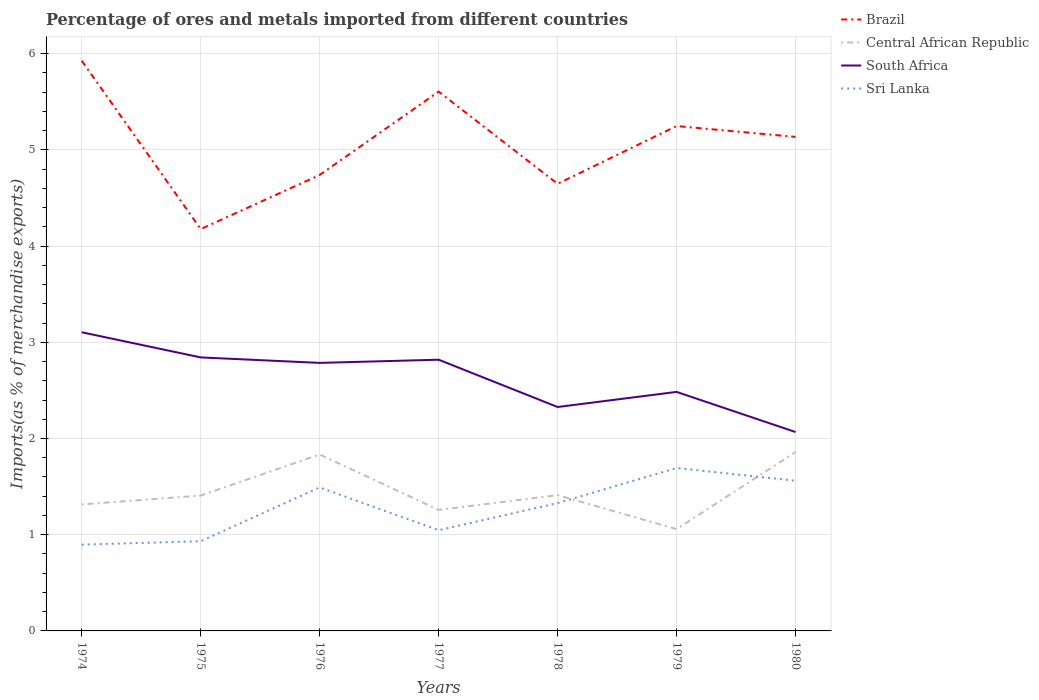How many different coloured lines are there?
Your response must be concise. 4. Is the number of lines equal to the number of legend labels?
Your answer should be very brief. Yes. Across all years, what is the maximum percentage of imports to different countries in Brazil?
Provide a short and direct response. 4.18. In which year was the percentage of imports to different countries in South Africa maximum?
Make the answer very short. 1980. What is the total percentage of imports to different countries in Sri Lanka in the graph?
Make the answer very short. 0.13. What is the difference between the highest and the second highest percentage of imports to different countries in Sri Lanka?
Your answer should be very brief. 0.8. What is the difference between the highest and the lowest percentage of imports to different countries in Brazil?
Keep it short and to the point. 4. How many lines are there?
Provide a short and direct response. 4. What is the difference between two consecutive major ticks on the Y-axis?
Offer a terse response. 1. Where does the legend appear in the graph?
Provide a succinct answer. Top right. How are the legend labels stacked?
Ensure brevity in your answer.  Vertical. What is the title of the graph?
Provide a succinct answer. Percentage of ores and metals imported from different countries. Does "Bahamas" appear as one of the legend labels in the graph?
Your answer should be very brief. No. What is the label or title of the X-axis?
Ensure brevity in your answer.  Years. What is the label or title of the Y-axis?
Provide a succinct answer. Imports(as % of merchandise exports). What is the Imports(as % of merchandise exports) in Brazil in 1974?
Offer a terse response. 5.93. What is the Imports(as % of merchandise exports) in Central African Republic in 1974?
Offer a terse response. 1.31. What is the Imports(as % of merchandise exports) in South Africa in 1974?
Provide a succinct answer. 3.1. What is the Imports(as % of merchandise exports) in Sri Lanka in 1974?
Provide a short and direct response. 0.9. What is the Imports(as % of merchandise exports) in Brazil in 1975?
Your answer should be very brief. 4.18. What is the Imports(as % of merchandise exports) of Central African Republic in 1975?
Offer a terse response. 1.41. What is the Imports(as % of merchandise exports) of South Africa in 1975?
Your answer should be compact. 2.84. What is the Imports(as % of merchandise exports) of Sri Lanka in 1975?
Your answer should be very brief. 0.93. What is the Imports(as % of merchandise exports) of Brazil in 1976?
Your answer should be compact. 4.74. What is the Imports(as % of merchandise exports) in Central African Republic in 1976?
Provide a succinct answer. 1.83. What is the Imports(as % of merchandise exports) in South Africa in 1976?
Your answer should be compact. 2.79. What is the Imports(as % of merchandise exports) of Sri Lanka in 1976?
Your answer should be compact. 1.49. What is the Imports(as % of merchandise exports) in Brazil in 1977?
Provide a succinct answer. 5.61. What is the Imports(as % of merchandise exports) of Central African Republic in 1977?
Offer a very short reply. 1.26. What is the Imports(as % of merchandise exports) in South Africa in 1977?
Provide a short and direct response. 2.82. What is the Imports(as % of merchandise exports) of Sri Lanka in 1977?
Your response must be concise. 1.05. What is the Imports(as % of merchandise exports) in Brazil in 1978?
Your response must be concise. 4.65. What is the Imports(as % of merchandise exports) of Central African Republic in 1978?
Your answer should be very brief. 1.41. What is the Imports(as % of merchandise exports) in South Africa in 1978?
Offer a terse response. 2.33. What is the Imports(as % of merchandise exports) of Sri Lanka in 1978?
Keep it short and to the point. 1.33. What is the Imports(as % of merchandise exports) in Brazil in 1979?
Offer a terse response. 5.25. What is the Imports(as % of merchandise exports) of Central African Republic in 1979?
Give a very brief answer. 1.06. What is the Imports(as % of merchandise exports) of South Africa in 1979?
Offer a terse response. 2.48. What is the Imports(as % of merchandise exports) in Sri Lanka in 1979?
Make the answer very short. 1.69. What is the Imports(as % of merchandise exports) in Brazil in 1980?
Your answer should be very brief. 5.14. What is the Imports(as % of merchandise exports) in Central African Republic in 1980?
Your answer should be compact. 1.86. What is the Imports(as % of merchandise exports) in South Africa in 1980?
Make the answer very short. 2.07. What is the Imports(as % of merchandise exports) of Sri Lanka in 1980?
Your answer should be very brief. 1.56. Across all years, what is the maximum Imports(as % of merchandise exports) in Brazil?
Your answer should be compact. 5.93. Across all years, what is the maximum Imports(as % of merchandise exports) in Central African Republic?
Give a very brief answer. 1.86. Across all years, what is the maximum Imports(as % of merchandise exports) in South Africa?
Provide a short and direct response. 3.1. Across all years, what is the maximum Imports(as % of merchandise exports) in Sri Lanka?
Offer a terse response. 1.69. Across all years, what is the minimum Imports(as % of merchandise exports) in Brazil?
Your response must be concise. 4.18. Across all years, what is the minimum Imports(as % of merchandise exports) in Central African Republic?
Keep it short and to the point. 1.06. Across all years, what is the minimum Imports(as % of merchandise exports) in South Africa?
Offer a very short reply. 2.07. Across all years, what is the minimum Imports(as % of merchandise exports) of Sri Lanka?
Provide a succinct answer. 0.9. What is the total Imports(as % of merchandise exports) in Brazil in the graph?
Provide a short and direct response. 35.48. What is the total Imports(as % of merchandise exports) of Central African Republic in the graph?
Make the answer very short. 10.14. What is the total Imports(as % of merchandise exports) in South Africa in the graph?
Give a very brief answer. 18.43. What is the total Imports(as % of merchandise exports) in Sri Lanka in the graph?
Ensure brevity in your answer.  8.95. What is the difference between the Imports(as % of merchandise exports) of Brazil in 1974 and that in 1975?
Offer a very short reply. 1.75. What is the difference between the Imports(as % of merchandise exports) in Central African Republic in 1974 and that in 1975?
Offer a terse response. -0.09. What is the difference between the Imports(as % of merchandise exports) in South Africa in 1974 and that in 1975?
Give a very brief answer. 0.26. What is the difference between the Imports(as % of merchandise exports) of Sri Lanka in 1974 and that in 1975?
Your response must be concise. -0.04. What is the difference between the Imports(as % of merchandise exports) of Brazil in 1974 and that in 1976?
Your answer should be compact. 1.19. What is the difference between the Imports(as % of merchandise exports) in Central African Republic in 1974 and that in 1976?
Offer a terse response. -0.52. What is the difference between the Imports(as % of merchandise exports) in South Africa in 1974 and that in 1976?
Give a very brief answer. 0.32. What is the difference between the Imports(as % of merchandise exports) of Sri Lanka in 1974 and that in 1976?
Offer a very short reply. -0.59. What is the difference between the Imports(as % of merchandise exports) in Brazil in 1974 and that in 1977?
Provide a short and direct response. 0.32. What is the difference between the Imports(as % of merchandise exports) in Central African Republic in 1974 and that in 1977?
Provide a short and direct response. 0.06. What is the difference between the Imports(as % of merchandise exports) in South Africa in 1974 and that in 1977?
Provide a short and direct response. 0.29. What is the difference between the Imports(as % of merchandise exports) in Sri Lanka in 1974 and that in 1977?
Give a very brief answer. -0.15. What is the difference between the Imports(as % of merchandise exports) of Brazil in 1974 and that in 1978?
Ensure brevity in your answer.  1.28. What is the difference between the Imports(as % of merchandise exports) of Central African Republic in 1974 and that in 1978?
Provide a short and direct response. -0.1. What is the difference between the Imports(as % of merchandise exports) in South Africa in 1974 and that in 1978?
Your answer should be compact. 0.78. What is the difference between the Imports(as % of merchandise exports) in Sri Lanka in 1974 and that in 1978?
Your response must be concise. -0.43. What is the difference between the Imports(as % of merchandise exports) in Brazil in 1974 and that in 1979?
Keep it short and to the point. 0.68. What is the difference between the Imports(as % of merchandise exports) in Central African Republic in 1974 and that in 1979?
Make the answer very short. 0.26. What is the difference between the Imports(as % of merchandise exports) of South Africa in 1974 and that in 1979?
Your answer should be compact. 0.62. What is the difference between the Imports(as % of merchandise exports) of Sri Lanka in 1974 and that in 1979?
Offer a very short reply. -0.8. What is the difference between the Imports(as % of merchandise exports) of Brazil in 1974 and that in 1980?
Your answer should be very brief. 0.79. What is the difference between the Imports(as % of merchandise exports) in Central African Republic in 1974 and that in 1980?
Offer a very short reply. -0.54. What is the difference between the Imports(as % of merchandise exports) of South Africa in 1974 and that in 1980?
Provide a succinct answer. 1.04. What is the difference between the Imports(as % of merchandise exports) of Sri Lanka in 1974 and that in 1980?
Keep it short and to the point. -0.66. What is the difference between the Imports(as % of merchandise exports) of Brazil in 1975 and that in 1976?
Give a very brief answer. -0.56. What is the difference between the Imports(as % of merchandise exports) in Central African Republic in 1975 and that in 1976?
Provide a short and direct response. -0.43. What is the difference between the Imports(as % of merchandise exports) in South Africa in 1975 and that in 1976?
Keep it short and to the point. 0.06. What is the difference between the Imports(as % of merchandise exports) of Sri Lanka in 1975 and that in 1976?
Make the answer very short. -0.56. What is the difference between the Imports(as % of merchandise exports) of Brazil in 1975 and that in 1977?
Offer a terse response. -1.43. What is the difference between the Imports(as % of merchandise exports) in Central African Republic in 1975 and that in 1977?
Your answer should be very brief. 0.15. What is the difference between the Imports(as % of merchandise exports) of South Africa in 1975 and that in 1977?
Your response must be concise. 0.02. What is the difference between the Imports(as % of merchandise exports) in Sri Lanka in 1975 and that in 1977?
Provide a succinct answer. -0.11. What is the difference between the Imports(as % of merchandise exports) in Brazil in 1975 and that in 1978?
Offer a terse response. -0.47. What is the difference between the Imports(as % of merchandise exports) of Central African Republic in 1975 and that in 1978?
Make the answer very short. -0. What is the difference between the Imports(as % of merchandise exports) in South Africa in 1975 and that in 1978?
Provide a short and direct response. 0.52. What is the difference between the Imports(as % of merchandise exports) in Sri Lanka in 1975 and that in 1978?
Ensure brevity in your answer.  -0.4. What is the difference between the Imports(as % of merchandise exports) in Brazil in 1975 and that in 1979?
Give a very brief answer. -1.07. What is the difference between the Imports(as % of merchandise exports) in Central African Republic in 1975 and that in 1979?
Your response must be concise. 0.35. What is the difference between the Imports(as % of merchandise exports) of South Africa in 1975 and that in 1979?
Provide a short and direct response. 0.36. What is the difference between the Imports(as % of merchandise exports) in Sri Lanka in 1975 and that in 1979?
Offer a very short reply. -0.76. What is the difference between the Imports(as % of merchandise exports) in Brazil in 1975 and that in 1980?
Your answer should be compact. -0.96. What is the difference between the Imports(as % of merchandise exports) in Central African Republic in 1975 and that in 1980?
Ensure brevity in your answer.  -0.45. What is the difference between the Imports(as % of merchandise exports) in South Africa in 1975 and that in 1980?
Ensure brevity in your answer.  0.78. What is the difference between the Imports(as % of merchandise exports) of Sri Lanka in 1975 and that in 1980?
Provide a short and direct response. -0.63. What is the difference between the Imports(as % of merchandise exports) of Brazil in 1976 and that in 1977?
Provide a succinct answer. -0.87. What is the difference between the Imports(as % of merchandise exports) of Central African Republic in 1976 and that in 1977?
Ensure brevity in your answer.  0.58. What is the difference between the Imports(as % of merchandise exports) of South Africa in 1976 and that in 1977?
Offer a terse response. -0.03. What is the difference between the Imports(as % of merchandise exports) of Sri Lanka in 1976 and that in 1977?
Your answer should be very brief. 0.44. What is the difference between the Imports(as % of merchandise exports) in Brazil in 1976 and that in 1978?
Your response must be concise. 0.09. What is the difference between the Imports(as % of merchandise exports) of Central African Republic in 1976 and that in 1978?
Your answer should be very brief. 0.42. What is the difference between the Imports(as % of merchandise exports) in South Africa in 1976 and that in 1978?
Your answer should be very brief. 0.46. What is the difference between the Imports(as % of merchandise exports) of Sri Lanka in 1976 and that in 1978?
Your answer should be very brief. 0.16. What is the difference between the Imports(as % of merchandise exports) in Brazil in 1976 and that in 1979?
Your answer should be very brief. -0.51. What is the difference between the Imports(as % of merchandise exports) of Central African Republic in 1976 and that in 1979?
Give a very brief answer. 0.78. What is the difference between the Imports(as % of merchandise exports) of South Africa in 1976 and that in 1979?
Offer a terse response. 0.3. What is the difference between the Imports(as % of merchandise exports) in Sri Lanka in 1976 and that in 1979?
Your response must be concise. -0.2. What is the difference between the Imports(as % of merchandise exports) in Brazil in 1976 and that in 1980?
Your answer should be compact. -0.4. What is the difference between the Imports(as % of merchandise exports) of Central African Republic in 1976 and that in 1980?
Make the answer very short. -0.02. What is the difference between the Imports(as % of merchandise exports) in South Africa in 1976 and that in 1980?
Ensure brevity in your answer.  0.72. What is the difference between the Imports(as % of merchandise exports) of Sri Lanka in 1976 and that in 1980?
Keep it short and to the point. -0.07. What is the difference between the Imports(as % of merchandise exports) of Central African Republic in 1977 and that in 1978?
Your answer should be compact. -0.15. What is the difference between the Imports(as % of merchandise exports) in South Africa in 1977 and that in 1978?
Keep it short and to the point. 0.49. What is the difference between the Imports(as % of merchandise exports) in Sri Lanka in 1977 and that in 1978?
Offer a terse response. -0.28. What is the difference between the Imports(as % of merchandise exports) of Brazil in 1977 and that in 1979?
Your answer should be very brief. 0.36. What is the difference between the Imports(as % of merchandise exports) in Central African Republic in 1977 and that in 1979?
Your response must be concise. 0.2. What is the difference between the Imports(as % of merchandise exports) of South Africa in 1977 and that in 1979?
Keep it short and to the point. 0.33. What is the difference between the Imports(as % of merchandise exports) in Sri Lanka in 1977 and that in 1979?
Offer a terse response. -0.65. What is the difference between the Imports(as % of merchandise exports) in Brazil in 1977 and that in 1980?
Provide a short and direct response. 0.47. What is the difference between the Imports(as % of merchandise exports) of Central African Republic in 1977 and that in 1980?
Ensure brevity in your answer.  -0.6. What is the difference between the Imports(as % of merchandise exports) of South Africa in 1977 and that in 1980?
Provide a succinct answer. 0.75. What is the difference between the Imports(as % of merchandise exports) of Sri Lanka in 1977 and that in 1980?
Provide a short and direct response. -0.51. What is the difference between the Imports(as % of merchandise exports) of Brazil in 1978 and that in 1979?
Provide a succinct answer. -0.6. What is the difference between the Imports(as % of merchandise exports) in Central African Republic in 1978 and that in 1979?
Your answer should be very brief. 0.35. What is the difference between the Imports(as % of merchandise exports) in South Africa in 1978 and that in 1979?
Offer a terse response. -0.16. What is the difference between the Imports(as % of merchandise exports) in Sri Lanka in 1978 and that in 1979?
Provide a short and direct response. -0.36. What is the difference between the Imports(as % of merchandise exports) of Brazil in 1978 and that in 1980?
Ensure brevity in your answer.  -0.49. What is the difference between the Imports(as % of merchandise exports) in Central African Republic in 1978 and that in 1980?
Make the answer very short. -0.45. What is the difference between the Imports(as % of merchandise exports) in South Africa in 1978 and that in 1980?
Offer a terse response. 0.26. What is the difference between the Imports(as % of merchandise exports) in Sri Lanka in 1978 and that in 1980?
Make the answer very short. -0.23. What is the difference between the Imports(as % of merchandise exports) in Brazil in 1979 and that in 1980?
Provide a short and direct response. 0.11. What is the difference between the Imports(as % of merchandise exports) of Central African Republic in 1979 and that in 1980?
Your response must be concise. -0.8. What is the difference between the Imports(as % of merchandise exports) of South Africa in 1979 and that in 1980?
Ensure brevity in your answer.  0.42. What is the difference between the Imports(as % of merchandise exports) of Sri Lanka in 1979 and that in 1980?
Your answer should be compact. 0.13. What is the difference between the Imports(as % of merchandise exports) of Brazil in 1974 and the Imports(as % of merchandise exports) of Central African Republic in 1975?
Keep it short and to the point. 4.52. What is the difference between the Imports(as % of merchandise exports) in Brazil in 1974 and the Imports(as % of merchandise exports) in South Africa in 1975?
Provide a short and direct response. 3.08. What is the difference between the Imports(as % of merchandise exports) of Brazil in 1974 and the Imports(as % of merchandise exports) of Sri Lanka in 1975?
Provide a short and direct response. 4.99. What is the difference between the Imports(as % of merchandise exports) of Central African Republic in 1974 and the Imports(as % of merchandise exports) of South Africa in 1975?
Provide a short and direct response. -1.53. What is the difference between the Imports(as % of merchandise exports) in Central African Republic in 1974 and the Imports(as % of merchandise exports) in Sri Lanka in 1975?
Your response must be concise. 0.38. What is the difference between the Imports(as % of merchandise exports) in South Africa in 1974 and the Imports(as % of merchandise exports) in Sri Lanka in 1975?
Ensure brevity in your answer.  2.17. What is the difference between the Imports(as % of merchandise exports) of Brazil in 1974 and the Imports(as % of merchandise exports) of Central African Republic in 1976?
Your response must be concise. 4.09. What is the difference between the Imports(as % of merchandise exports) in Brazil in 1974 and the Imports(as % of merchandise exports) in South Africa in 1976?
Make the answer very short. 3.14. What is the difference between the Imports(as % of merchandise exports) of Brazil in 1974 and the Imports(as % of merchandise exports) of Sri Lanka in 1976?
Keep it short and to the point. 4.43. What is the difference between the Imports(as % of merchandise exports) in Central African Republic in 1974 and the Imports(as % of merchandise exports) in South Africa in 1976?
Provide a succinct answer. -1.47. What is the difference between the Imports(as % of merchandise exports) of Central African Republic in 1974 and the Imports(as % of merchandise exports) of Sri Lanka in 1976?
Offer a terse response. -0.18. What is the difference between the Imports(as % of merchandise exports) of South Africa in 1974 and the Imports(as % of merchandise exports) of Sri Lanka in 1976?
Your answer should be compact. 1.61. What is the difference between the Imports(as % of merchandise exports) in Brazil in 1974 and the Imports(as % of merchandise exports) in Central African Republic in 1977?
Make the answer very short. 4.67. What is the difference between the Imports(as % of merchandise exports) in Brazil in 1974 and the Imports(as % of merchandise exports) in South Africa in 1977?
Give a very brief answer. 3.11. What is the difference between the Imports(as % of merchandise exports) of Brazil in 1974 and the Imports(as % of merchandise exports) of Sri Lanka in 1977?
Your answer should be very brief. 4.88. What is the difference between the Imports(as % of merchandise exports) in Central African Republic in 1974 and the Imports(as % of merchandise exports) in South Africa in 1977?
Provide a short and direct response. -1.5. What is the difference between the Imports(as % of merchandise exports) in Central African Republic in 1974 and the Imports(as % of merchandise exports) in Sri Lanka in 1977?
Give a very brief answer. 0.27. What is the difference between the Imports(as % of merchandise exports) in South Africa in 1974 and the Imports(as % of merchandise exports) in Sri Lanka in 1977?
Offer a very short reply. 2.06. What is the difference between the Imports(as % of merchandise exports) in Brazil in 1974 and the Imports(as % of merchandise exports) in Central African Republic in 1978?
Your answer should be compact. 4.51. What is the difference between the Imports(as % of merchandise exports) of Brazil in 1974 and the Imports(as % of merchandise exports) of South Africa in 1978?
Give a very brief answer. 3.6. What is the difference between the Imports(as % of merchandise exports) of Brazil in 1974 and the Imports(as % of merchandise exports) of Sri Lanka in 1978?
Make the answer very short. 4.6. What is the difference between the Imports(as % of merchandise exports) of Central African Republic in 1974 and the Imports(as % of merchandise exports) of South Africa in 1978?
Make the answer very short. -1.01. What is the difference between the Imports(as % of merchandise exports) of Central African Republic in 1974 and the Imports(as % of merchandise exports) of Sri Lanka in 1978?
Your answer should be compact. -0.01. What is the difference between the Imports(as % of merchandise exports) of South Africa in 1974 and the Imports(as % of merchandise exports) of Sri Lanka in 1978?
Keep it short and to the point. 1.78. What is the difference between the Imports(as % of merchandise exports) in Brazil in 1974 and the Imports(as % of merchandise exports) in Central African Republic in 1979?
Keep it short and to the point. 4.87. What is the difference between the Imports(as % of merchandise exports) in Brazil in 1974 and the Imports(as % of merchandise exports) in South Africa in 1979?
Keep it short and to the point. 3.44. What is the difference between the Imports(as % of merchandise exports) of Brazil in 1974 and the Imports(as % of merchandise exports) of Sri Lanka in 1979?
Make the answer very short. 4.23. What is the difference between the Imports(as % of merchandise exports) in Central African Republic in 1974 and the Imports(as % of merchandise exports) in South Africa in 1979?
Offer a very short reply. -1.17. What is the difference between the Imports(as % of merchandise exports) of Central African Republic in 1974 and the Imports(as % of merchandise exports) of Sri Lanka in 1979?
Your answer should be compact. -0.38. What is the difference between the Imports(as % of merchandise exports) of South Africa in 1974 and the Imports(as % of merchandise exports) of Sri Lanka in 1979?
Make the answer very short. 1.41. What is the difference between the Imports(as % of merchandise exports) in Brazil in 1974 and the Imports(as % of merchandise exports) in Central African Republic in 1980?
Ensure brevity in your answer.  4.07. What is the difference between the Imports(as % of merchandise exports) in Brazil in 1974 and the Imports(as % of merchandise exports) in South Africa in 1980?
Give a very brief answer. 3.86. What is the difference between the Imports(as % of merchandise exports) in Brazil in 1974 and the Imports(as % of merchandise exports) in Sri Lanka in 1980?
Provide a succinct answer. 4.37. What is the difference between the Imports(as % of merchandise exports) in Central African Republic in 1974 and the Imports(as % of merchandise exports) in South Africa in 1980?
Provide a short and direct response. -0.75. What is the difference between the Imports(as % of merchandise exports) of Central African Republic in 1974 and the Imports(as % of merchandise exports) of Sri Lanka in 1980?
Provide a succinct answer. -0.25. What is the difference between the Imports(as % of merchandise exports) of South Africa in 1974 and the Imports(as % of merchandise exports) of Sri Lanka in 1980?
Offer a very short reply. 1.54. What is the difference between the Imports(as % of merchandise exports) in Brazil in 1975 and the Imports(as % of merchandise exports) in Central African Republic in 1976?
Your response must be concise. 2.34. What is the difference between the Imports(as % of merchandise exports) of Brazil in 1975 and the Imports(as % of merchandise exports) of South Africa in 1976?
Offer a terse response. 1.39. What is the difference between the Imports(as % of merchandise exports) of Brazil in 1975 and the Imports(as % of merchandise exports) of Sri Lanka in 1976?
Your response must be concise. 2.69. What is the difference between the Imports(as % of merchandise exports) in Central African Republic in 1975 and the Imports(as % of merchandise exports) in South Africa in 1976?
Offer a terse response. -1.38. What is the difference between the Imports(as % of merchandise exports) of Central African Republic in 1975 and the Imports(as % of merchandise exports) of Sri Lanka in 1976?
Keep it short and to the point. -0.08. What is the difference between the Imports(as % of merchandise exports) in South Africa in 1975 and the Imports(as % of merchandise exports) in Sri Lanka in 1976?
Keep it short and to the point. 1.35. What is the difference between the Imports(as % of merchandise exports) of Brazil in 1975 and the Imports(as % of merchandise exports) of Central African Republic in 1977?
Provide a short and direct response. 2.92. What is the difference between the Imports(as % of merchandise exports) in Brazil in 1975 and the Imports(as % of merchandise exports) in South Africa in 1977?
Provide a short and direct response. 1.36. What is the difference between the Imports(as % of merchandise exports) in Brazil in 1975 and the Imports(as % of merchandise exports) in Sri Lanka in 1977?
Ensure brevity in your answer.  3.13. What is the difference between the Imports(as % of merchandise exports) in Central African Republic in 1975 and the Imports(as % of merchandise exports) in South Africa in 1977?
Provide a succinct answer. -1.41. What is the difference between the Imports(as % of merchandise exports) of Central African Republic in 1975 and the Imports(as % of merchandise exports) of Sri Lanka in 1977?
Give a very brief answer. 0.36. What is the difference between the Imports(as % of merchandise exports) in South Africa in 1975 and the Imports(as % of merchandise exports) in Sri Lanka in 1977?
Ensure brevity in your answer.  1.8. What is the difference between the Imports(as % of merchandise exports) in Brazil in 1975 and the Imports(as % of merchandise exports) in Central African Republic in 1978?
Keep it short and to the point. 2.77. What is the difference between the Imports(as % of merchandise exports) of Brazil in 1975 and the Imports(as % of merchandise exports) of South Africa in 1978?
Offer a terse response. 1.85. What is the difference between the Imports(as % of merchandise exports) of Brazil in 1975 and the Imports(as % of merchandise exports) of Sri Lanka in 1978?
Your answer should be compact. 2.85. What is the difference between the Imports(as % of merchandise exports) of Central African Republic in 1975 and the Imports(as % of merchandise exports) of South Africa in 1978?
Make the answer very short. -0.92. What is the difference between the Imports(as % of merchandise exports) of Central African Republic in 1975 and the Imports(as % of merchandise exports) of Sri Lanka in 1978?
Ensure brevity in your answer.  0.08. What is the difference between the Imports(as % of merchandise exports) in South Africa in 1975 and the Imports(as % of merchandise exports) in Sri Lanka in 1978?
Offer a very short reply. 1.51. What is the difference between the Imports(as % of merchandise exports) of Brazil in 1975 and the Imports(as % of merchandise exports) of Central African Republic in 1979?
Make the answer very short. 3.12. What is the difference between the Imports(as % of merchandise exports) of Brazil in 1975 and the Imports(as % of merchandise exports) of South Africa in 1979?
Make the answer very short. 1.69. What is the difference between the Imports(as % of merchandise exports) in Brazil in 1975 and the Imports(as % of merchandise exports) in Sri Lanka in 1979?
Your answer should be very brief. 2.48. What is the difference between the Imports(as % of merchandise exports) of Central African Republic in 1975 and the Imports(as % of merchandise exports) of South Africa in 1979?
Your answer should be compact. -1.08. What is the difference between the Imports(as % of merchandise exports) of Central African Republic in 1975 and the Imports(as % of merchandise exports) of Sri Lanka in 1979?
Offer a terse response. -0.29. What is the difference between the Imports(as % of merchandise exports) in South Africa in 1975 and the Imports(as % of merchandise exports) in Sri Lanka in 1979?
Make the answer very short. 1.15. What is the difference between the Imports(as % of merchandise exports) of Brazil in 1975 and the Imports(as % of merchandise exports) of Central African Republic in 1980?
Keep it short and to the point. 2.32. What is the difference between the Imports(as % of merchandise exports) in Brazil in 1975 and the Imports(as % of merchandise exports) in South Africa in 1980?
Provide a succinct answer. 2.11. What is the difference between the Imports(as % of merchandise exports) of Brazil in 1975 and the Imports(as % of merchandise exports) of Sri Lanka in 1980?
Make the answer very short. 2.62. What is the difference between the Imports(as % of merchandise exports) of Central African Republic in 1975 and the Imports(as % of merchandise exports) of South Africa in 1980?
Offer a very short reply. -0.66. What is the difference between the Imports(as % of merchandise exports) in Central African Republic in 1975 and the Imports(as % of merchandise exports) in Sri Lanka in 1980?
Your answer should be compact. -0.15. What is the difference between the Imports(as % of merchandise exports) of South Africa in 1975 and the Imports(as % of merchandise exports) of Sri Lanka in 1980?
Keep it short and to the point. 1.28. What is the difference between the Imports(as % of merchandise exports) in Brazil in 1976 and the Imports(as % of merchandise exports) in Central African Republic in 1977?
Offer a terse response. 3.48. What is the difference between the Imports(as % of merchandise exports) of Brazil in 1976 and the Imports(as % of merchandise exports) of South Africa in 1977?
Offer a very short reply. 1.92. What is the difference between the Imports(as % of merchandise exports) of Brazil in 1976 and the Imports(as % of merchandise exports) of Sri Lanka in 1977?
Make the answer very short. 3.69. What is the difference between the Imports(as % of merchandise exports) of Central African Republic in 1976 and the Imports(as % of merchandise exports) of South Africa in 1977?
Your answer should be very brief. -0.99. What is the difference between the Imports(as % of merchandise exports) in Central African Republic in 1976 and the Imports(as % of merchandise exports) in Sri Lanka in 1977?
Provide a short and direct response. 0.79. What is the difference between the Imports(as % of merchandise exports) of South Africa in 1976 and the Imports(as % of merchandise exports) of Sri Lanka in 1977?
Keep it short and to the point. 1.74. What is the difference between the Imports(as % of merchandise exports) in Brazil in 1976 and the Imports(as % of merchandise exports) in Central African Republic in 1978?
Ensure brevity in your answer.  3.33. What is the difference between the Imports(as % of merchandise exports) of Brazil in 1976 and the Imports(as % of merchandise exports) of South Africa in 1978?
Give a very brief answer. 2.41. What is the difference between the Imports(as % of merchandise exports) of Brazil in 1976 and the Imports(as % of merchandise exports) of Sri Lanka in 1978?
Provide a succinct answer. 3.41. What is the difference between the Imports(as % of merchandise exports) in Central African Republic in 1976 and the Imports(as % of merchandise exports) in South Africa in 1978?
Offer a very short reply. -0.49. What is the difference between the Imports(as % of merchandise exports) of Central African Republic in 1976 and the Imports(as % of merchandise exports) of Sri Lanka in 1978?
Your response must be concise. 0.51. What is the difference between the Imports(as % of merchandise exports) of South Africa in 1976 and the Imports(as % of merchandise exports) of Sri Lanka in 1978?
Offer a very short reply. 1.46. What is the difference between the Imports(as % of merchandise exports) in Brazil in 1976 and the Imports(as % of merchandise exports) in Central African Republic in 1979?
Your answer should be very brief. 3.68. What is the difference between the Imports(as % of merchandise exports) of Brazil in 1976 and the Imports(as % of merchandise exports) of South Africa in 1979?
Your answer should be compact. 2.25. What is the difference between the Imports(as % of merchandise exports) of Brazil in 1976 and the Imports(as % of merchandise exports) of Sri Lanka in 1979?
Ensure brevity in your answer.  3.05. What is the difference between the Imports(as % of merchandise exports) in Central African Republic in 1976 and the Imports(as % of merchandise exports) in South Africa in 1979?
Provide a short and direct response. -0.65. What is the difference between the Imports(as % of merchandise exports) of Central African Republic in 1976 and the Imports(as % of merchandise exports) of Sri Lanka in 1979?
Your response must be concise. 0.14. What is the difference between the Imports(as % of merchandise exports) of South Africa in 1976 and the Imports(as % of merchandise exports) of Sri Lanka in 1979?
Provide a succinct answer. 1.09. What is the difference between the Imports(as % of merchandise exports) in Brazil in 1976 and the Imports(as % of merchandise exports) in Central African Republic in 1980?
Offer a terse response. 2.88. What is the difference between the Imports(as % of merchandise exports) of Brazil in 1976 and the Imports(as % of merchandise exports) of South Africa in 1980?
Offer a very short reply. 2.67. What is the difference between the Imports(as % of merchandise exports) in Brazil in 1976 and the Imports(as % of merchandise exports) in Sri Lanka in 1980?
Your answer should be very brief. 3.18. What is the difference between the Imports(as % of merchandise exports) of Central African Republic in 1976 and the Imports(as % of merchandise exports) of South Africa in 1980?
Provide a short and direct response. -0.23. What is the difference between the Imports(as % of merchandise exports) of Central African Republic in 1976 and the Imports(as % of merchandise exports) of Sri Lanka in 1980?
Offer a very short reply. 0.27. What is the difference between the Imports(as % of merchandise exports) in South Africa in 1976 and the Imports(as % of merchandise exports) in Sri Lanka in 1980?
Offer a terse response. 1.22. What is the difference between the Imports(as % of merchandise exports) in Brazil in 1977 and the Imports(as % of merchandise exports) in Central African Republic in 1978?
Your answer should be very brief. 4.19. What is the difference between the Imports(as % of merchandise exports) of Brazil in 1977 and the Imports(as % of merchandise exports) of South Africa in 1978?
Offer a terse response. 3.28. What is the difference between the Imports(as % of merchandise exports) of Brazil in 1977 and the Imports(as % of merchandise exports) of Sri Lanka in 1978?
Keep it short and to the point. 4.28. What is the difference between the Imports(as % of merchandise exports) in Central African Republic in 1977 and the Imports(as % of merchandise exports) in South Africa in 1978?
Offer a terse response. -1.07. What is the difference between the Imports(as % of merchandise exports) in Central African Republic in 1977 and the Imports(as % of merchandise exports) in Sri Lanka in 1978?
Offer a terse response. -0.07. What is the difference between the Imports(as % of merchandise exports) of South Africa in 1977 and the Imports(as % of merchandise exports) of Sri Lanka in 1978?
Ensure brevity in your answer.  1.49. What is the difference between the Imports(as % of merchandise exports) of Brazil in 1977 and the Imports(as % of merchandise exports) of Central African Republic in 1979?
Keep it short and to the point. 4.55. What is the difference between the Imports(as % of merchandise exports) of Brazil in 1977 and the Imports(as % of merchandise exports) of South Africa in 1979?
Ensure brevity in your answer.  3.12. What is the difference between the Imports(as % of merchandise exports) of Brazil in 1977 and the Imports(as % of merchandise exports) of Sri Lanka in 1979?
Provide a succinct answer. 3.91. What is the difference between the Imports(as % of merchandise exports) of Central African Republic in 1977 and the Imports(as % of merchandise exports) of South Africa in 1979?
Keep it short and to the point. -1.23. What is the difference between the Imports(as % of merchandise exports) of Central African Republic in 1977 and the Imports(as % of merchandise exports) of Sri Lanka in 1979?
Give a very brief answer. -0.44. What is the difference between the Imports(as % of merchandise exports) in South Africa in 1977 and the Imports(as % of merchandise exports) in Sri Lanka in 1979?
Keep it short and to the point. 1.13. What is the difference between the Imports(as % of merchandise exports) in Brazil in 1977 and the Imports(as % of merchandise exports) in Central African Republic in 1980?
Provide a short and direct response. 3.75. What is the difference between the Imports(as % of merchandise exports) of Brazil in 1977 and the Imports(as % of merchandise exports) of South Africa in 1980?
Keep it short and to the point. 3.54. What is the difference between the Imports(as % of merchandise exports) in Brazil in 1977 and the Imports(as % of merchandise exports) in Sri Lanka in 1980?
Your answer should be compact. 4.04. What is the difference between the Imports(as % of merchandise exports) of Central African Republic in 1977 and the Imports(as % of merchandise exports) of South Africa in 1980?
Offer a very short reply. -0.81. What is the difference between the Imports(as % of merchandise exports) in Central African Republic in 1977 and the Imports(as % of merchandise exports) in Sri Lanka in 1980?
Give a very brief answer. -0.3. What is the difference between the Imports(as % of merchandise exports) of South Africa in 1977 and the Imports(as % of merchandise exports) of Sri Lanka in 1980?
Your answer should be very brief. 1.26. What is the difference between the Imports(as % of merchandise exports) in Brazil in 1978 and the Imports(as % of merchandise exports) in Central African Republic in 1979?
Ensure brevity in your answer.  3.59. What is the difference between the Imports(as % of merchandise exports) in Brazil in 1978 and the Imports(as % of merchandise exports) in South Africa in 1979?
Your answer should be very brief. 2.16. What is the difference between the Imports(as % of merchandise exports) in Brazil in 1978 and the Imports(as % of merchandise exports) in Sri Lanka in 1979?
Your response must be concise. 2.95. What is the difference between the Imports(as % of merchandise exports) of Central African Republic in 1978 and the Imports(as % of merchandise exports) of South Africa in 1979?
Your answer should be very brief. -1.07. What is the difference between the Imports(as % of merchandise exports) in Central African Republic in 1978 and the Imports(as % of merchandise exports) in Sri Lanka in 1979?
Make the answer very short. -0.28. What is the difference between the Imports(as % of merchandise exports) in South Africa in 1978 and the Imports(as % of merchandise exports) in Sri Lanka in 1979?
Offer a terse response. 0.63. What is the difference between the Imports(as % of merchandise exports) of Brazil in 1978 and the Imports(as % of merchandise exports) of Central African Republic in 1980?
Offer a terse response. 2.79. What is the difference between the Imports(as % of merchandise exports) of Brazil in 1978 and the Imports(as % of merchandise exports) of South Africa in 1980?
Offer a very short reply. 2.58. What is the difference between the Imports(as % of merchandise exports) of Brazil in 1978 and the Imports(as % of merchandise exports) of Sri Lanka in 1980?
Offer a terse response. 3.09. What is the difference between the Imports(as % of merchandise exports) in Central African Republic in 1978 and the Imports(as % of merchandise exports) in South Africa in 1980?
Give a very brief answer. -0.66. What is the difference between the Imports(as % of merchandise exports) of Central African Republic in 1978 and the Imports(as % of merchandise exports) of Sri Lanka in 1980?
Provide a succinct answer. -0.15. What is the difference between the Imports(as % of merchandise exports) in South Africa in 1978 and the Imports(as % of merchandise exports) in Sri Lanka in 1980?
Keep it short and to the point. 0.77. What is the difference between the Imports(as % of merchandise exports) of Brazil in 1979 and the Imports(as % of merchandise exports) of Central African Republic in 1980?
Your response must be concise. 3.39. What is the difference between the Imports(as % of merchandise exports) of Brazil in 1979 and the Imports(as % of merchandise exports) of South Africa in 1980?
Provide a succinct answer. 3.18. What is the difference between the Imports(as % of merchandise exports) of Brazil in 1979 and the Imports(as % of merchandise exports) of Sri Lanka in 1980?
Your response must be concise. 3.69. What is the difference between the Imports(as % of merchandise exports) of Central African Republic in 1979 and the Imports(as % of merchandise exports) of South Africa in 1980?
Make the answer very short. -1.01. What is the difference between the Imports(as % of merchandise exports) of Central African Republic in 1979 and the Imports(as % of merchandise exports) of Sri Lanka in 1980?
Your response must be concise. -0.5. What is the difference between the Imports(as % of merchandise exports) in South Africa in 1979 and the Imports(as % of merchandise exports) in Sri Lanka in 1980?
Ensure brevity in your answer.  0.92. What is the average Imports(as % of merchandise exports) in Brazil per year?
Make the answer very short. 5.07. What is the average Imports(as % of merchandise exports) in Central African Republic per year?
Your answer should be very brief. 1.45. What is the average Imports(as % of merchandise exports) in South Africa per year?
Your answer should be very brief. 2.63. What is the average Imports(as % of merchandise exports) of Sri Lanka per year?
Provide a succinct answer. 1.28. In the year 1974, what is the difference between the Imports(as % of merchandise exports) of Brazil and Imports(as % of merchandise exports) of Central African Republic?
Keep it short and to the point. 4.61. In the year 1974, what is the difference between the Imports(as % of merchandise exports) in Brazil and Imports(as % of merchandise exports) in South Africa?
Your response must be concise. 2.82. In the year 1974, what is the difference between the Imports(as % of merchandise exports) in Brazil and Imports(as % of merchandise exports) in Sri Lanka?
Provide a short and direct response. 5.03. In the year 1974, what is the difference between the Imports(as % of merchandise exports) in Central African Republic and Imports(as % of merchandise exports) in South Africa?
Provide a succinct answer. -1.79. In the year 1974, what is the difference between the Imports(as % of merchandise exports) of Central African Republic and Imports(as % of merchandise exports) of Sri Lanka?
Your answer should be very brief. 0.42. In the year 1974, what is the difference between the Imports(as % of merchandise exports) of South Africa and Imports(as % of merchandise exports) of Sri Lanka?
Provide a succinct answer. 2.21. In the year 1975, what is the difference between the Imports(as % of merchandise exports) of Brazil and Imports(as % of merchandise exports) of Central African Republic?
Offer a terse response. 2.77. In the year 1975, what is the difference between the Imports(as % of merchandise exports) of Brazil and Imports(as % of merchandise exports) of South Africa?
Provide a short and direct response. 1.33. In the year 1975, what is the difference between the Imports(as % of merchandise exports) of Brazil and Imports(as % of merchandise exports) of Sri Lanka?
Offer a terse response. 3.24. In the year 1975, what is the difference between the Imports(as % of merchandise exports) of Central African Republic and Imports(as % of merchandise exports) of South Africa?
Make the answer very short. -1.44. In the year 1975, what is the difference between the Imports(as % of merchandise exports) in Central African Republic and Imports(as % of merchandise exports) in Sri Lanka?
Your answer should be compact. 0.47. In the year 1975, what is the difference between the Imports(as % of merchandise exports) of South Africa and Imports(as % of merchandise exports) of Sri Lanka?
Provide a succinct answer. 1.91. In the year 1976, what is the difference between the Imports(as % of merchandise exports) in Brazil and Imports(as % of merchandise exports) in Central African Republic?
Ensure brevity in your answer.  2.91. In the year 1976, what is the difference between the Imports(as % of merchandise exports) of Brazil and Imports(as % of merchandise exports) of South Africa?
Provide a short and direct response. 1.95. In the year 1976, what is the difference between the Imports(as % of merchandise exports) in Brazil and Imports(as % of merchandise exports) in Sri Lanka?
Provide a short and direct response. 3.25. In the year 1976, what is the difference between the Imports(as % of merchandise exports) of Central African Republic and Imports(as % of merchandise exports) of South Africa?
Offer a terse response. -0.95. In the year 1976, what is the difference between the Imports(as % of merchandise exports) in Central African Republic and Imports(as % of merchandise exports) in Sri Lanka?
Give a very brief answer. 0.34. In the year 1976, what is the difference between the Imports(as % of merchandise exports) in South Africa and Imports(as % of merchandise exports) in Sri Lanka?
Make the answer very short. 1.29. In the year 1977, what is the difference between the Imports(as % of merchandise exports) in Brazil and Imports(as % of merchandise exports) in Central African Republic?
Give a very brief answer. 4.35. In the year 1977, what is the difference between the Imports(as % of merchandise exports) of Brazil and Imports(as % of merchandise exports) of South Africa?
Ensure brevity in your answer.  2.79. In the year 1977, what is the difference between the Imports(as % of merchandise exports) in Brazil and Imports(as % of merchandise exports) in Sri Lanka?
Ensure brevity in your answer.  4.56. In the year 1977, what is the difference between the Imports(as % of merchandise exports) in Central African Republic and Imports(as % of merchandise exports) in South Africa?
Keep it short and to the point. -1.56. In the year 1977, what is the difference between the Imports(as % of merchandise exports) in Central African Republic and Imports(as % of merchandise exports) in Sri Lanka?
Provide a short and direct response. 0.21. In the year 1977, what is the difference between the Imports(as % of merchandise exports) of South Africa and Imports(as % of merchandise exports) of Sri Lanka?
Give a very brief answer. 1.77. In the year 1978, what is the difference between the Imports(as % of merchandise exports) of Brazil and Imports(as % of merchandise exports) of Central African Republic?
Offer a very short reply. 3.24. In the year 1978, what is the difference between the Imports(as % of merchandise exports) of Brazil and Imports(as % of merchandise exports) of South Africa?
Give a very brief answer. 2.32. In the year 1978, what is the difference between the Imports(as % of merchandise exports) in Brazil and Imports(as % of merchandise exports) in Sri Lanka?
Your answer should be compact. 3.32. In the year 1978, what is the difference between the Imports(as % of merchandise exports) of Central African Republic and Imports(as % of merchandise exports) of South Africa?
Ensure brevity in your answer.  -0.92. In the year 1978, what is the difference between the Imports(as % of merchandise exports) of Central African Republic and Imports(as % of merchandise exports) of Sri Lanka?
Offer a terse response. 0.08. In the year 1978, what is the difference between the Imports(as % of merchandise exports) of South Africa and Imports(as % of merchandise exports) of Sri Lanka?
Offer a very short reply. 1. In the year 1979, what is the difference between the Imports(as % of merchandise exports) of Brazil and Imports(as % of merchandise exports) of Central African Republic?
Offer a terse response. 4.19. In the year 1979, what is the difference between the Imports(as % of merchandise exports) in Brazil and Imports(as % of merchandise exports) in South Africa?
Give a very brief answer. 2.76. In the year 1979, what is the difference between the Imports(as % of merchandise exports) in Brazil and Imports(as % of merchandise exports) in Sri Lanka?
Your answer should be very brief. 3.55. In the year 1979, what is the difference between the Imports(as % of merchandise exports) in Central African Republic and Imports(as % of merchandise exports) in South Africa?
Your response must be concise. -1.43. In the year 1979, what is the difference between the Imports(as % of merchandise exports) in Central African Republic and Imports(as % of merchandise exports) in Sri Lanka?
Provide a short and direct response. -0.64. In the year 1979, what is the difference between the Imports(as % of merchandise exports) in South Africa and Imports(as % of merchandise exports) in Sri Lanka?
Keep it short and to the point. 0.79. In the year 1980, what is the difference between the Imports(as % of merchandise exports) in Brazil and Imports(as % of merchandise exports) in Central African Republic?
Provide a succinct answer. 3.28. In the year 1980, what is the difference between the Imports(as % of merchandise exports) in Brazil and Imports(as % of merchandise exports) in South Africa?
Keep it short and to the point. 3.07. In the year 1980, what is the difference between the Imports(as % of merchandise exports) in Brazil and Imports(as % of merchandise exports) in Sri Lanka?
Make the answer very short. 3.57. In the year 1980, what is the difference between the Imports(as % of merchandise exports) in Central African Republic and Imports(as % of merchandise exports) in South Africa?
Offer a terse response. -0.21. In the year 1980, what is the difference between the Imports(as % of merchandise exports) of Central African Republic and Imports(as % of merchandise exports) of Sri Lanka?
Make the answer very short. 0.3. In the year 1980, what is the difference between the Imports(as % of merchandise exports) in South Africa and Imports(as % of merchandise exports) in Sri Lanka?
Keep it short and to the point. 0.51. What is the ratio of the Imports(as % of merchandise exports) in Brazil in 1974 to that in 1975?
Keep it short and to the point. 1.42. What is the ratio of the Imports(as % of merchandise exports) of Central African Republic in 1974 to that in 1975?
Ensure brevity in your answer.  0.93. What is the ratio of the Imports(as % of merchandise exports) of South Africa in 1974 to that in 1975?
Make the answer very short. 1.09. What is the ratio of the Imports(as % of merchandise exports) in Sri Lanka in 1974 to that in 1975?
Offer a very short reply. 0.96. What is the ratio of the Imports(as % of merchandise exports) in Brazil in 1974 to that in 1976?
Keep it short and to the point. 1.25. What is the ratio of the Imports(as % of merchandise exports) of Central African Republic in 1974 to that in 1976?
Keep it short and to the point. 0.72. What is the ratio of the Imports(as % of merchandise exports) of South Africa in 1974 to that in 1976?
Your answer should be very brief. 1.11. What is the ratio of the Imports(as % of merchandise exports) in Sri Lanka in 1974 to that in 1976?
Keep it short and to the point. 0.6. What is the ratio of the Imports(as % of merchandise exports) of Brazil in 1974 to that in 1977?
Make the answer very short. 1.06. What is the ratio of the Imports(as % of merchandise exports) in Central African Republic in 1974 to that in 1977?
Provide a succinct answer. 1.05. What is the ratio of the Imports(as % of merchandise exports) in South Africa in 1974 to that in 1977?
Give a very brief answer. 1.1. What is the ratio of the Imports(as % of merchandise exports) of Sri Lanka in 1974 to that in 1977?
Keep it short and to the point. 0.86. What is the ratio of the Imports(as % of merchandise exports) of Brazil in 1974 to that in 1978?
Keep it short and to the point. 1.28. What is the ratio of the Imports(as % of merchandise exports) of Central African Republic in 1974 to that in 1978?
Your answer should be very brief. 0.93. What is the ratio of the Imports(as % of merchandise exports) of South Africa in 1974 to that in 1978?
Give a very brief answer. 1.33. What is the ratio of the Imports(as % of merchandise exports) in Sri Lanka in 1974 to that in 1978?
Make the answer very short. 0.67. What is the ratio of the Imports(as % of merchandise exports) in Brazil in 1974 to that in 1979?
Give a very brief answer. 1.13. What is the ratio of the Imports(as % of merchandise exports) in Central African Republic in 1974 to that in 1979?
Provide a succinct answer. 1.24. What is the ratio of the Imports(as % of merchandise exports) of South Africa in 1974 to that in 1979?
Keep it short and to the point. 1.25. What is the ratio of the Imports(as % of merchandise exports) in Sri Lanka in 1974 to that in 1979?
Give a very brief answer. 0.53. What is the ratio of the Imports(as % of merchandise exports) in Brazil in 1974 to that in 1980?
Keep it short and to the point. 1.15. What is the ratio of the Imports(as % of merchandise exports) in Central African Republic in 1974 to that in 1980?
Your response must be concise. 0.71. What is the ratio of the Imports(as % of merchandise exports) of South Africa in 1974 to that in 1980?
Ensure brevity in your answer.  1.5. What is the ratio of the Imports(as % of merchandise exports) of Sri Lanka in 1974 to that in 1980?
Your answer should be very brief. 0.57. What is the ratio of the Imports(as % of merchandise exports) in Brazil in 1975 to that in 1976?
Provide a short and direct response. 0.88. What is the ratio of the Imports(as % of merchandise exports) of Central African Republic in 1975 to that in 1976?
Ensure brevity in your answer.  0.77. What is the ratio of the Imports(as % of merchandise exports) in South Africa in 1975 to that in 1976?
Give a very brief answer. 1.02. What is the ratio of the Imports(as % of merchandise exports) of Sri Lanka in 1975 to that in 1976?
Offer a very short reply. 0.63. What is the ratio of the Imports(as % of merchandise exports) in Brazil in 1975 to that in 1977?
Give a very brief answer. 0.75. What is the ratio of the Imports(as % of merchandise exports) in Central African Republic in 1975 to that in 1977?
Offer a terse response. 1.12. What is the ratio of the Imports(as % of merchandise exports) of South Africa in 1975 to that in 1977?
Give a very brief answer. 1.01. What is the ratio of the Imports(as % of merchandise exports) in Sri Lanka in 1975 to that in 1977?
Offer a very short reply. 0.89. What is the ratio of the Imports(as % of merchandise exports) of Brazil in 1975 to that in 1978?
Provide a succinct answer. 0.9. What is the ratio of the Imports(as % of merchandise exports) in South Africa in 1975 to that in 1978?
Give a very brief answer. 1.22. What is the ratio of the Imports(as % of merchandise exports) in Sri Lanka in 1975 to that in 1978?
Your answer should be compact. 0.7. What is the ratio of the Imports(as % of merchandise exports) in Brazil in 1975 to that in 1979?
Give a very brief answer. 0.8. What is the ratio of the Imports(as % of merchandise exports) in Central African Republic in 1975 to that in 1979?
Offer a very short reply. 1.33. What is the ratio of the Imports(as % of merchandise exports) in South Africa in 1975 to that in 1979?
Provide a succinct answer. 1.14. What is the ratio of the Imports(as % of merchandise exports) in Sri Lanka in 1975 to that in 1979?
Make the answer very short. 0.55. What is the ratio of the Imports(as % of merchandise exports) in Brazil in 1975 to that in 1980?
Offer a terse response. 0.81. What is the ratio of the Imports(as % of merchandise exports) in Central African Republic in 1975 to that in 1980?
Provide a succinct answer. 0.76. What is the ratio of the Imports(as % of merchandise exports) in South Africa in 1975 to that in 1980?
Ensure brevity in your answer.  1.38. What is the ratio of the Imports(as % of merchandise exports) of Sri Lanka in 1975 to that in 1980?
Make the answer very short. 0.6. What is the ratio of the Imports(as % of merchandise exports) of Brazil in 1976 to that in 1977?
Provide a short and direct response. 0.85. What is the ratio of the Imports(as % of merchandise exports) of Central African Republic in 1976 to that in 1977?
Keep it short and to the point. 1.46. What is the ratio of the Imports(as % of merchandise exports) in South Africa in 1976 to that in 1977?
Your response must be concise. 0.99. What is the ratio of the Imports(as % of merchandise exports) in Sri Lanka in 1976 to that in 1977?
Offer a very short reply. 1.43. What is the ratio of the Imports(as % of merchandise exports) in Brazil in 1976 to that in 1978?
Your response must be concise. 1.02. What is the ratio of the Imports(as % of merchandise exports) in Central African Republic in 1976 to that in 1978?
Your answer should be compact. 1.3. What is the ratio of the Imports(as % of merchandise exports) of South Africa in 1976 to that in 1978?
Provide a short and direct response. 1.2. What is the ratio of the Imports(as % of merchandise exports) in Sri Lanka in 1976 to that in 1978?
Your answer should be compact. 1.12. What is the ratio of the Imports(as % of merchandise exports) in Brazil in 1976 to that in 1979?
Provide a short and direct response. 0.9. What is the ratio of the Imports(as % of merchandise exports) of Central African Republic in 1976 to that in 1979?
Give a very brief answer. 1.73. What is the ratio of the Imports(as % of merchandise exports) of South Africa in 1976 to that in 1979?
Offer a terse response. 1.12. What is the ratio of the Imports(as % of merchandise exports) in Sri Lanka in 1976 to that in 1979?
Make the answer very short. 0.88. What is the ratio of the Imports(as % of merchandise exports) of Brazil in 1976 to that in 1980?
Your answer should be compact. 0.92. What is the ratio of the Imports(as % of merchandise exports) in Central African Republic in 1976 to that in 1980?
Offer a terse response. 0.99. What is the ratio of the Imports(as % of merchandise exports) of South Africa in 1976 to that in 1980?
Provide a short and direct response. 1.35. What is the ratio of the Imports(as % of merchandise exports) of Sri Lanka in 1976 to that in 1980?
Provide a short and direct response. 0.96. What is the ratio of the Imports(as % of merchandise exports) in Brazil in 1977 to that in 1978?
Your response must be concise. 1.21. What is the ratio of the Imports(as % of merchandise exports) in Central African Republic in 1977 to that in 1978?
Provide a short and direct response. 0.89. What is the ratio of the Imports(as % of merchandise exports) of South Africa in 1977 to that in 1978?
Offer a very short reply. 1.21. What is the ratio of the Imports(as % of merchandise exports) of Sri Lanka in 1977 to that in 1978?
Make the answer very short. 0.79. What is the ratio of the Imports(as % of merchandise exports) in Brazil in 1977 to that in 1979?
Offer a very short reply. 1.07. What is the ratio of the Imports(as % of merchandise exports) in Central African Republic in 1977 to that in 1979?
Ensure brevity in your answer.  1.19. What is the ratio of the Imports(as % of merchandise exports) of South Africa in 1977 to that in 1979?
Provide a short and direct response. 1.13. What is the ratio of the Imports(as % of merchandise exports) in Sri Lanka in 1977 to that in 1979?
Keep it short and to the point. 0.62. What is the ratio of the Imports(as % of merchandise exports) in Brazil in 1977 to that in 1980?
Make the answer very short. 1.09. What is the ratio of the Imports(as % of merchandise exports) of Central African Republic in 1977 to that in 1980?
Make the answer very short. 0.68. What is the ratio of the Imports(as % of merchandise exports) in South Africa in 1977 to that in 1980?
Ensure brevity in your answer.  1.36. What is the ratio of the Imports(as % of merchandise exports) of Sri Lanka in 1977 to that in 1980?
Make the answer very short. 0.67. What is the ratio of the Imports(as % of merchandise exports) in Brazil in 1978 to that in 1979?
Keep it short and to the point. 0.89. What is the ratio of the Imports(as % of merchandise exports) of Central African Republic in 1978 to that in 1979?
Your answer should be very brief. 1.33. What is the ratio of the Imports(as % of merchandise exports) of South Africa in 1978 to that in 1979?
Your response must be concise. 0.94. What is the ratio of the Imports(as % of merchandise exports) in Sri Lanka in 1978 to that in 1979?
Give a very brief answer. 0.78. What is the ratio of the Imports(as % of merchandise exports) of Brazil in 1978 to that in 1980?
Your answer should be very brief. 0.91. What is the ratio of the Imports(as % of merchandise exports) in Central African Republic in 1978 to that in 1980?
Provide a succinct answer. 0.76. What is the ratio of the Imports(as % of merchandise exports) in South Africa in 1978 to that in 1980?
Provide a short and direct response. 1.13. What is the ratio of the Imports(as % of merchandise exports) of Sri Lanka in 1978 to that in 1980?
Provide a succinct answer. 0.85. What is the ratio of the Imports(as % of merchandise exports) of Brazil in 1979 to that in 1980?
Make the answer very short. 1.02. What is the ratio of the Imports(as % of merchandise exports) of Central African Republic in 1979 to that in 1980?
Your answer should be compact. 0.57. What is the ratio of the Imports(as % of merchandise exports) of South Africa in 1979 to that in 1980?
Your answer should be very brief. 1.2. What is the ratio of the Imports(as % of merchandise exports) in Sri Lanka in 1979 to that in 1980?
Your response must be concise. 1.08. What is the difference between the highest and the second highest Imports(as % of merchandise exports) in Brazil?
Make the answer very short. 0.32. What is the difference between the highest and the second highest Imports(as % of merchandise exports) in Central African Republic?
Provide a succinct answer. 0.02. What is the difference between the highest and the second highest Imports(as % of merchandise exports) of South Africa?
Offer a very short reply. 0.26. What is the difference between the highest and the second highest Imports(as % of merchandise exports) in Sri Lanka?
Offer a terse response. 0.13. What is the difference between the highest and the lowest Imports(as % of merchandise exports) in Brazil?
Provide a succinct answer. 1.75. What is the difference between the highest and the lowest Imports(as % of merchandise exports) in Central African Republic?
Make the answer very short. 0.8. What is the difference between the highest and the lowest Imports(as % of merchandise exports) of South Africa?
Your response must be concise. 1.04. What is the difference between the highest and the lowest Imports(as % of merchandise exports) of Sri Lanka?
Make the answer very short. 0.8. 